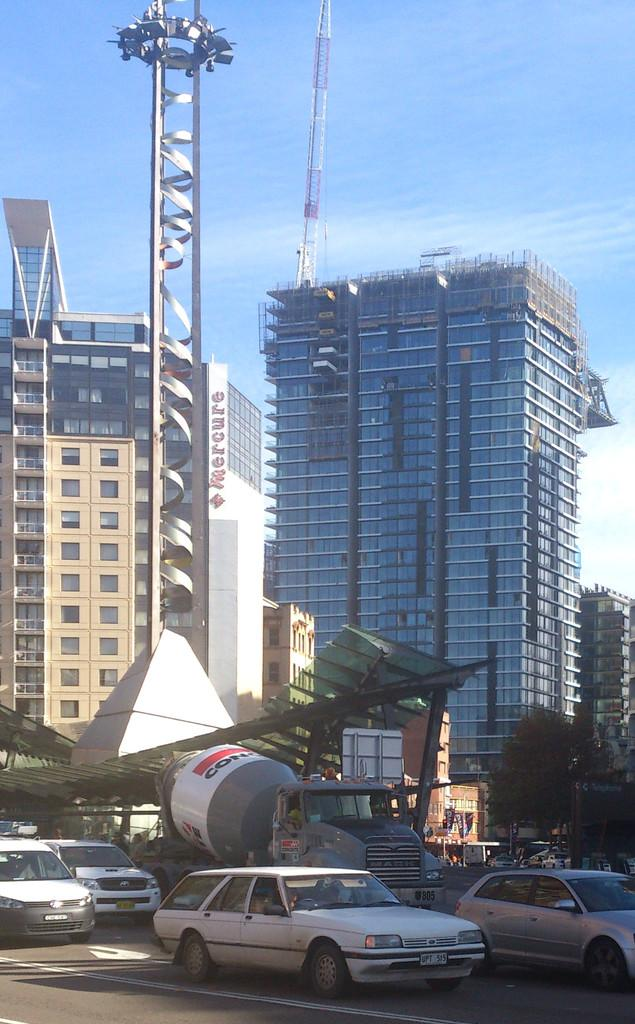What is happening at the bottom of the image? There are cars moving on the road at the bottom of the image. What can be seen in the middle of the image? There are buildings in the middle of the image. What is visible at the top of the image? The sky is visible at the top of the image. Can you tell me how many tramps are jumping on the buildings in the image? There are no tramps present in the image; it features cars on the road and buildings in the middle. Who is the expert in the image? There is no expert depicted in the image; it is a scene of cars, buildings, and the sky. 